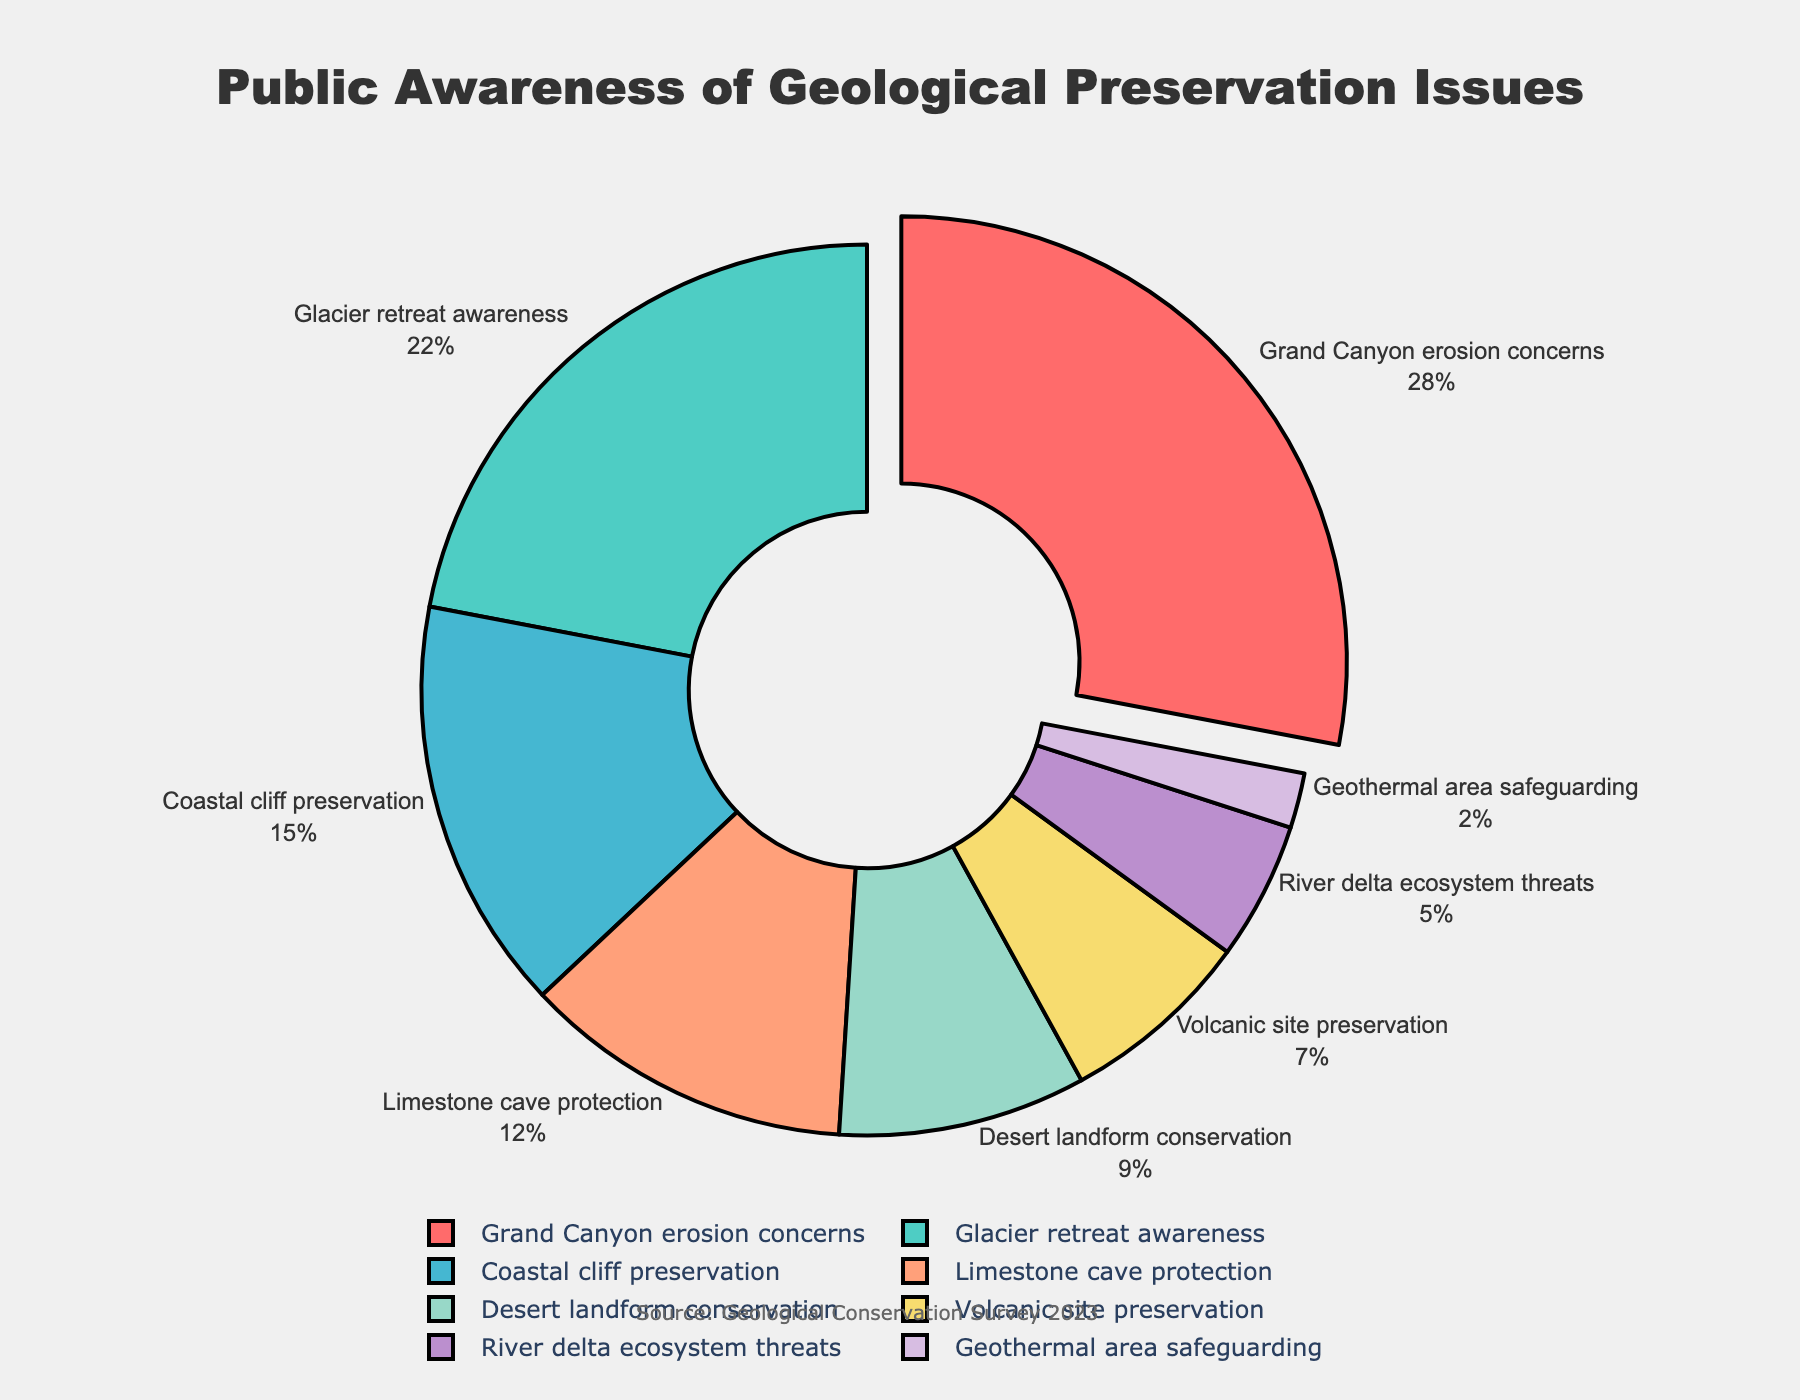Which geological preservation issue has the highest public awareness? The largest segment in the pie chart is pulled out slightly, indicating the issue with the highest awareness. This segment represents "Grand Canyon erosion concerns" with 28%.
Answer: Grand Canyon erosion concerns Which geological preservation issue has the lowest public awareness? The smallest segment in the pie chart indicates the issue with the lowest awareness. This segment represents "Geothermal area safeguarding" with 2%.
Answer: Geothermal area safeguarding What is the combined percentage of awareness for glacier retreat and volcanic site preservation? From the pie chart, the percentages for glacier retreat and volcanic site preservation are 22% and 7%, respectively. Adding these together gives 22% + 7% = 29%.
Answer: 29% Which issues have a higher awareness than desert landform conservation? Desert landform conservation has 9% awareness. The issues with higher percentages are Grand Canyon erosion concerns (28%), Glacier retreat awareness (22%), Coastal cliff preservation (15%), and Limestone cave protection (12%).
Answer: Grand Canyon erosion concerns, Glacier retreat awareness, Coastal cliff preservation, Limestone cave protection What is the difference in public awareness between coastal cliff preservation and river delta ecosystem threats? Coastal cliff preservation has 15% awareness, while river delta ecosystem threats have 5%. The difference is 15% - 5% = 10%.
Answer: 10% What percentage of public awareness is covered by issues related to both volcanic site preservation and geothermal area safeguarding? Volcanic site preservation has 7% and geothermal area safeguarding has 2%. Adding these gives 7% + 2% = 9%.
Answer: 9% Which segment is represented with the color blue in the pie chart? The blue-colored segment in the pie chart represents the issue "Grand Canyon erosion concerns".
Answer: Grand Canyon erosion concerns How much greater is the public awareness for glacier retreat awareness compared to limestone cave protection? The awareness for glacier retreat is 22%, and for limestone cave protection is 12%. The difference is 22% - 12% = 10%.
Answer: 10% 